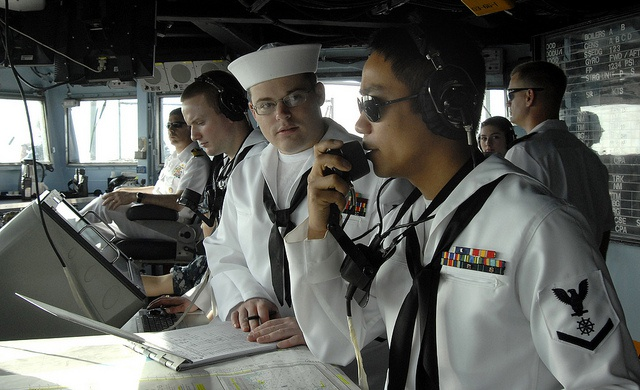Describe the objects in this image and their specific colors. I can see people in gray, black, darkgray, and maroon tones, people in gray, darkgray, black, and lightgray tones, people in gray and black tones, people in gray, black, and darkgray tones, and people in gray, black, white, and darkgray tones in this image. 